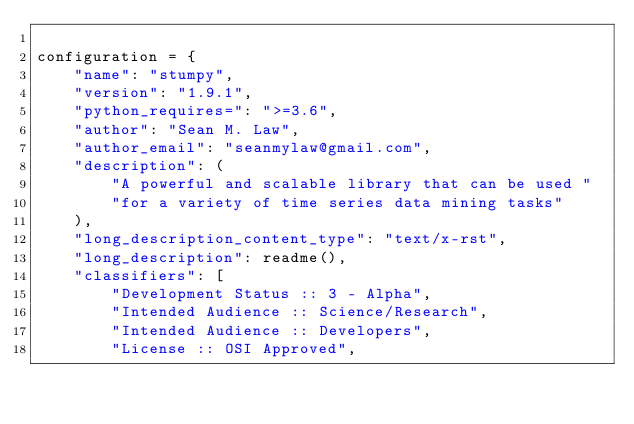Convert code to text. <code><loc_0><loc_0><loc_500><loc_500><_Python_>
configuration = {
    "name": "stumpy",
    "version": "1.9.1",
    "python_requires=": ">=3.6",
    "author": "Sean M. Law",
    "author_email": "seanmylaw@gmail.com",
    "description": (
        "A powerful and scalable library that can be used "
        "for a variety of time series data mining tasks"
    ),
    "long_description_content_type": "text/x-rst",
    "long_description": readme(),
    "classifiers": [
        "Development Status :: 3 - Alpha",
        "Intended Audience :: Science/Research",
        "Intended Audience :: Developers",
        "License :: OSI Approved",</code> 